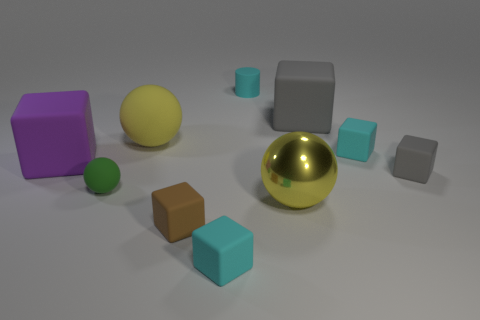What shape is the gray object to the left of the small cyan matte block that is on the right side of the tiny cylinder? cube 